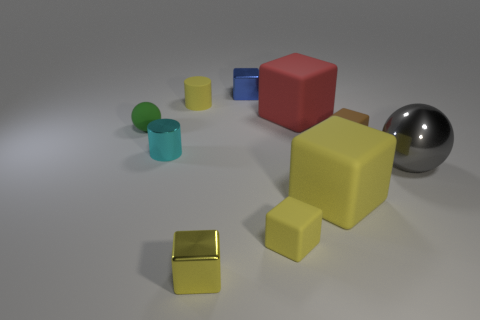What textures do the objects in the image have? The objects include various textures: the red and blue cubes have a matte texture; the yellow cube is also matte, but in a lighter shade; the gold cube and silver sphere have reflective, metallic textures; and the green and smaller blue cylinders have a semi-gloss texture.  Which objects are closest to the sphere? The large red cube and a smaller yellow cube are the objects closest to the reflective silver sphere. 